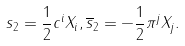<formula> <loc_0><loc_0><loc_500><loc_500>s _ { 2 } = \frac { 1 } { 2 } c ^ { i } X _ { i } , \overline { s } _ { 2 } = - \frac { 1 } { 2 } \pi ^ { j } X _ { j } .</formula> 